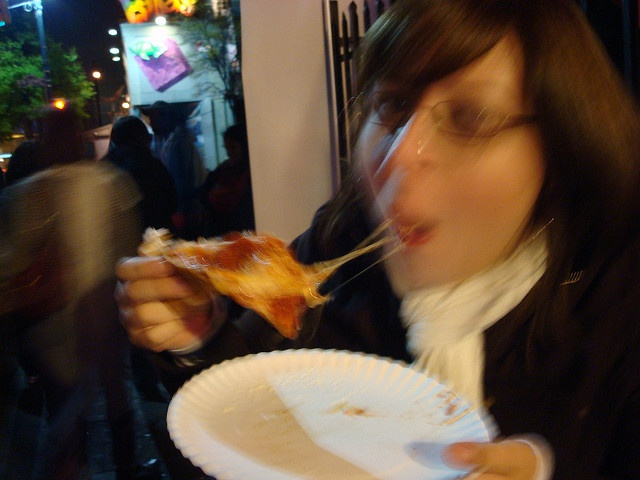Describe the objects in this image and their specific colors. I can see people in darkblue, black, brown, maroon, and gray tones, pizza in darkblue, red, black, maroon, and orange tones, people in darkblue, black, gray, and maroon tones, people in darkblue, black, and teal tones, and people in darkblue, black, navy, and blue tones in this image. 